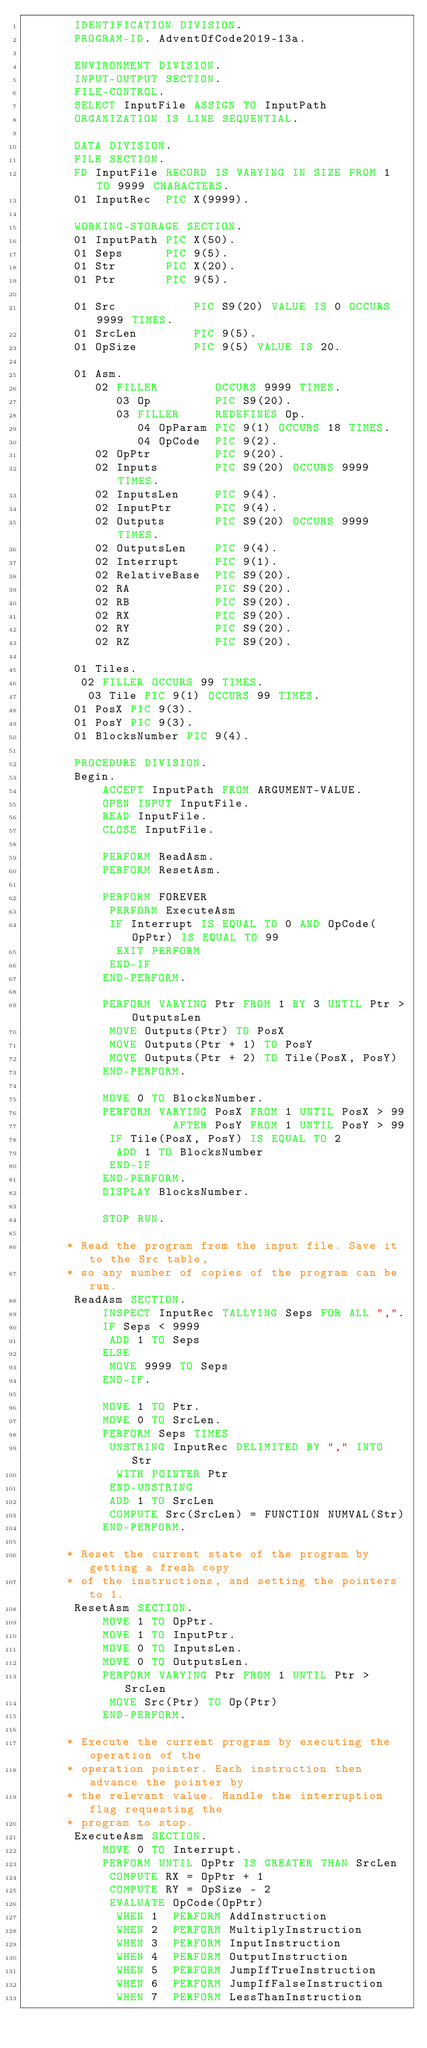<code> <loc_0><loc_0><loc_500><loc_500><_COBOL_>       IDENTIFICATION DIVISION.
       PROGRAM-ID. AdventOfCode2019-13a.

       ENVIRONMENT DIVISION.
       INPUT-OUTPUT SECTION.
       FILE-CONTROL.
       SELECT InputFile ASSIGN TO InputPath
       ORGANIZATION IS LINE SEQUENTIAL.

       DATA DIVISION.
       FILE SECTION.
       FD InputFile RECORD IS VARYING IN SIZE FROM 1 TO 9999 CHARACTERS.
       01 InputRec  PIC X(9999).

       WORKING-STORAGE SECTION.
       01 InputPath PIC X(50).
       01 Seps      PIC 9(5).
       01 Str       PIC X(20).
       01 Ptr       PIC 9(5).

       01 Src           PIC S9(20) VALUE IS 0 OCCURS 9999 TIMES.
       01 SrcLen        PIC 9(5).
       01 OpSize        PIC 9(5) VALUE IS 20.

       01 Asm.
          02 FILLER        OCCURS 9999 TIMES.
             03 Op         PIC S9(20).
             03 FILLER     REDEFINES Op.
                04 OpParam PIC 9(1) OCCURS 18 TIMES.
                04 OpCode  PIC 9(2).
          02 OpPtr         PIC 9(20).
          02 Inputs        PIC S9(20) OCCURS 9999 TIMES.
          02 InputsLen     PIC 9(4).
          02 InputPtr      PIC 9(4).
          02 Outputs       PIC S9(20) OCCURS 9999 TIMES.
          02 OutputsLen    PIC 9(4).
          02 Interrupt     PIC 9(1).
          02 RelativeBase  PIC S9(20).
          02 RA            PIC S9(20).
          02 RB            PIC S9(20).
          02 RX            PIC S9(20).
          02 RY            PIC S9(20).
          02 RZ            PIC S9(20).

       01 Tiles.
        02 FILLER OCCURS 99 TIMES.
         03 Tile PIC 9(1) OCCURS 99 TIMES.
       01 PosX PIC 9(3).
       01 PosY PIC 9(3).
       01 BlocksNumber PIC 9(4).

       PROCEDURE DIVISION.
       Begin.
           ACCEPT InputPath FROM ARGUMENT-VALUE.
           OPEN INPUT InputFile.
           READ InputFile.
           CLOSE InputFile.

           PERFORM ReadAsm.
           PERFORM ResetAsm.

           PERFORM FOREVER
            PERFORM ExecuteAsm
            IF Interrupt IS EQUAL TO 0 AND OpCode(OpPtr) IS EQUAL TO 99
             EXIT PERFORM
            END-IF
           END-PERFORM.

           PERFORM VARYING Ptr FROM 1 BY 3 UNTIL Ptr > OutputsLen
            MOVE Outputs(Ptr) TO PosX
            MOVE Outputs(Ptr + 1) TO PosY
            MOVE Outputs(Ptr + 2) TO Tile(PosX, PosY)
           END-PERFORM.

           MOVE 0 TO BlocksNumber.
           PERFORM VARYING PosX FROM 1 UNTIL PosX > 99
                     AFTER PosY FROM 1 UNTIL PosY > 99
            IF Tile(PosX, PosY) IS EQUAL TO 2 
             ADD 1 TO BlocksNumber
            END-IF
           END-PERFORM.
           DISPLAY BlocksNumber.

           STOP RUN.

      * Read the program from the input file. Save it to the Src table,
      * so any number of copies of the program can be run.
       ReadAsm SECTION.
           INSPECT InputRec TALLYING Seps FOR ALL ",".
           IF Seps < 9999
            ADD 1 TO Seps
           ELSE
            MOVE 9999 TO Seps
           END-IF.

           MOVE 1 TO Ptr.
           MOVE 0 TO SrcLen.
           PERFORM Seps TIMES
            UNSTRING InputRec DELIMITED BY "," INTO Str
             WITH POINTER Ptr
            END-UNSTRING
            ADD 1 TO SrcLen
            COMPUTE Src(SrcLen) = FUNCTION NUMVAL(Str)
           END-PERFORM.

      * Reset the current state of the program by getting a fresh copy
      * of the instructions, and setting the pointers to 1.
       ResetAsm SECTION.
           MOVE 1 TO OpPtr.
           MOVE 1 TO InputPtr.
           MOVE 0 TO InputsLen.
           MOVE 0 TO OutputsLen.
           PERFORM VARYING Ptr FROM 1 UNTIL Ptr > SrcLen
            MOVE Src(Ptr) TO Op(Ptr)
           END-PERFORM.

      * Execute the current program by executing the operation of the
      * operation pointer. Each instruction then advance the pointer by
      * the relevant value. Handle the interruption flag requesting the
      * program to stop.
       ExecuteAsm SECTION.
           MOVE 0 TO Interrupt.
           PERFORM UNTIL OpPtr IS GREATER THAN SrcLen
            COMPUTE RX = OpPtr + 1
            COMPUTE RY = OpSize - 2
            EVALUATE OpCode(OpPtr)
             WHEN 1  PERFORM AddInstruction
             WHEN 2  PERFORM MultiplyInstruction
             WHEN 3  PERFORM InputInstruction
             WHEN 4  PERFORM OutputInstruction
             WHEN 5  PERFORM JumpIfTrueInstruction
             WHEN 6  PERFORM JumpIfFalseInstruction
             WHEN 7  PERFORM LessThanInstruction</code> 